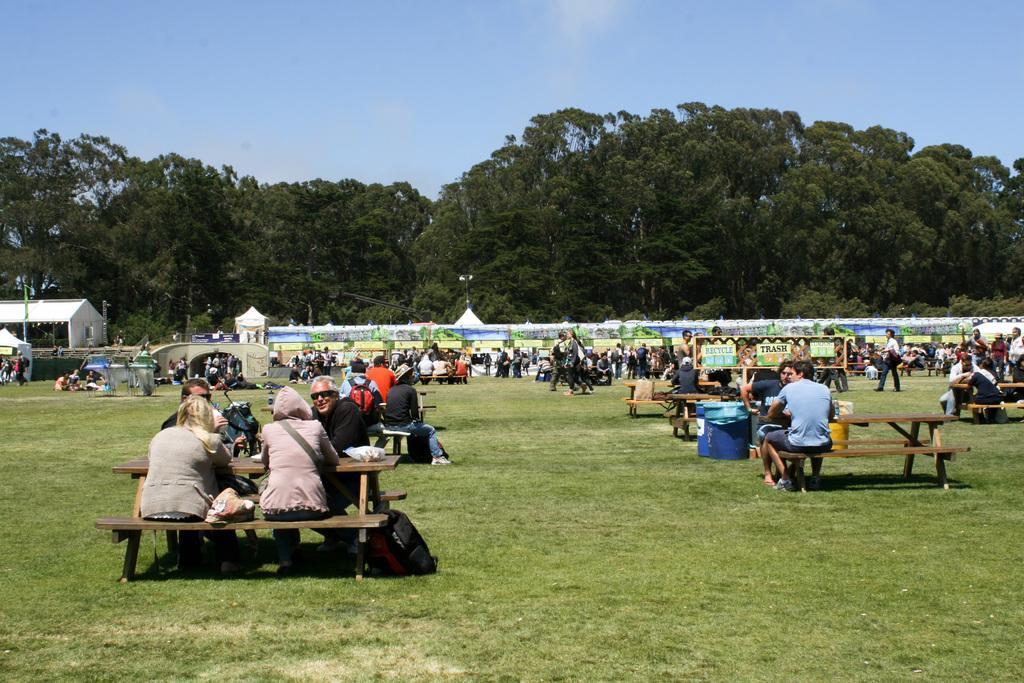Please provide a concise description of this image. In this image there are group of people sitting on the benches , group of people standing, there are stalls, a board , trees, and in the background there is sky. 